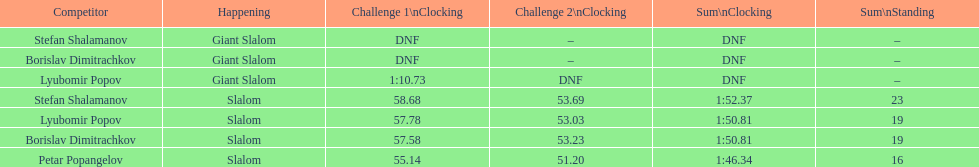Who was last in the slalom overall? Stefan Shalamanov. 